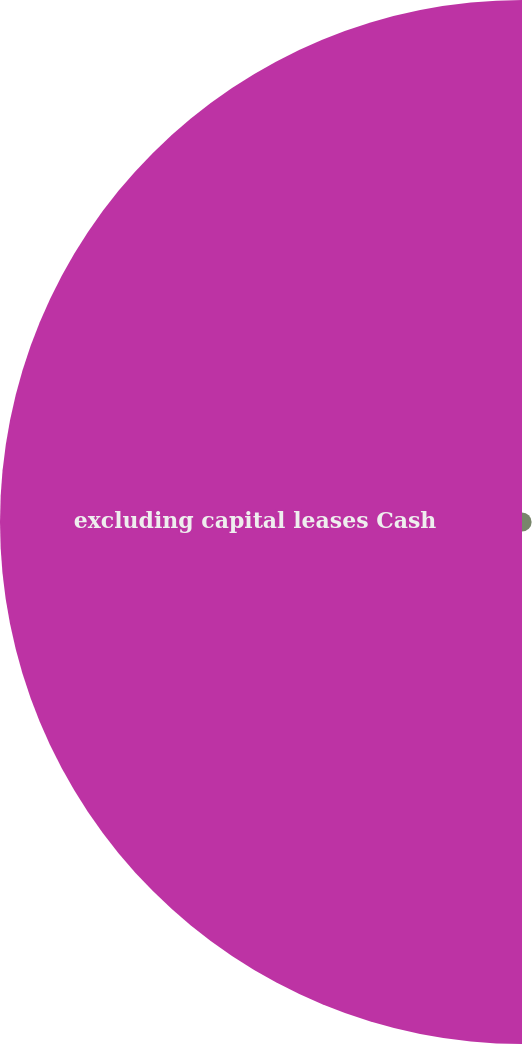Convert chart to OTSL. <chart><loc_0><loc_0><loc_500><loc_500><pie_chart><fcel>South African Facility(7)<fcel>excluding capital leases Cash<nl><fcel>1.81%<fcel>98.19%<nl></chart> 